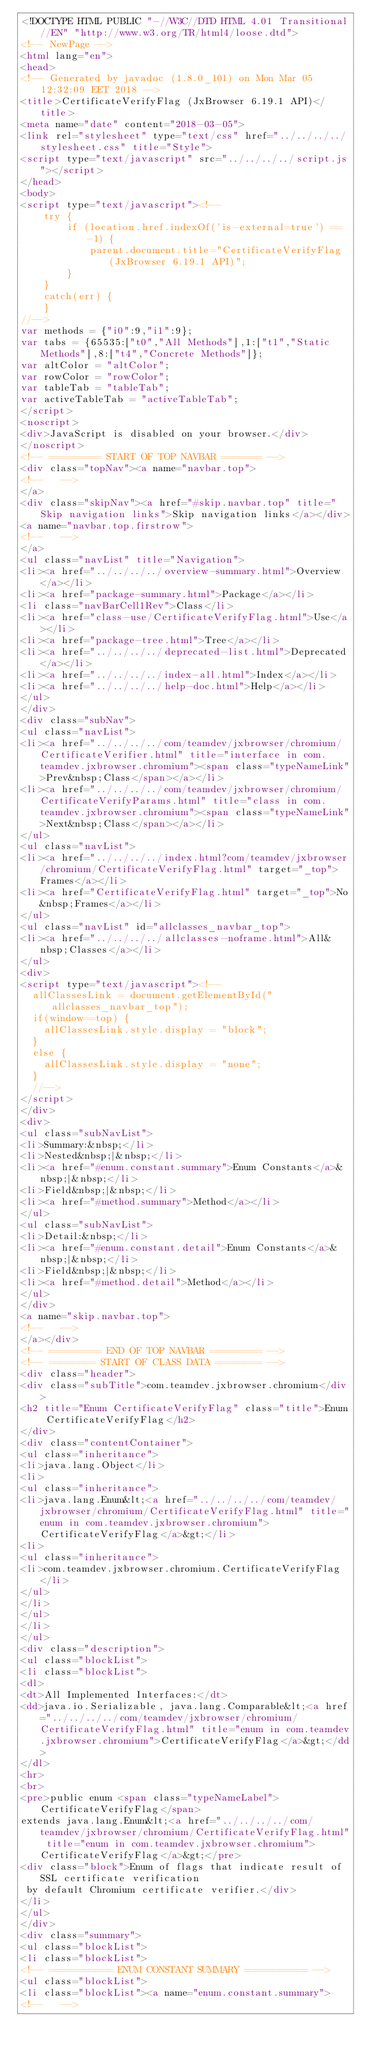Convert code to text. <code><loc_0><loc_0><loc_500><loc_500><_HTML_><!DOCTYPE HTML PUBLIC "-//W3C//DTD HTML 4.01 Transitional//EN" "http://www.w3.org/TR/html4/loose.dtd">
<!-- NewPage -->
<html lang="en">
<head>
<!-- Generated by javadoc (1.8.0_101) on Mon Mar 05 12:32:09 EET 2018 -->
<title>CertificateVerifyFlag (JxBrowser 6.19.1 API)</title>
<meta name="date" content="2018-03-05">
<link rel="stylesheet" type="text/css" href="../../../../stylesheet.css" title="Style">
<script type="text/javascript" src="../../../../script.js"></script>
</head>
<body>
<script type="text/javascript"><!--
    try {
        if (location.href.indexOf('is-external=true') == -1) {
            parent.document.title="CertificateVerifyFlag (JxBrowser 6.19.1 API)";
        }
    }
    catch(err) {
    }
//-->
var methods = {"i0":9,"i1":9};
var tabs = {65535:["t0","All Methods"],1:["t1","Static Methods"],8:["t4","Concrete Methods"]};
var altColor = "altColor";
var rowColor = "rowColor";
var tableTab = "tableTab";
var activeTableTab = "activeTableTab";
</script>
<noscript>
<div>JavaScript is disabled on your browser.</div>
</noscript>
<!-- ========= START OF TOP NAVBAR ======= -->
<div class="topNav"><a name="navbar.top">
<!--   -->
</a>
<div class="skipNav"><a href="#skip.navbar.top" title="Skip navigation links">Skip navigation links</a></div>
<a name="navbar.top.firstrow">
<!--   -->
</a>
<ul class="navList" title="Navigation">
<li><a href="../../../../overview-summary.html">Overview</a></li>
<li><a href="package-summary.html">Package</a></li>
<li class="navBarCell1Rev">Class</li>
<li><a href="class-use/CertificateVerifyFlag.html">Use</a></li>
<li><a href="package-tree.html">Tree</a></li>
<li><a href="../../../../deprecated-list.html">Deprecated</a></li>
<li><a href="../../../../index-all.html">Index</a></li>
<li><a href="../../../../help-doc.html">Help</a></li>
</ul>
</div>
<div class="subNav">
<ul class="navList">
<li><a href="../../../../com/teamdev/jxbrowser/chromium/CertificateVerifier.html" title="interface in com.teamdev.jxbrowser.chromium"><span class="typeNameLink">Prev&nbsp;Class</span></a></li>
<li><a href="../../../../com/teamdev/jxbrowser/chromium/CertificateVerifyParams.html" title="class in com.teamdev.jxbrowser.chromium"><span class="typeNameLink">Next&nbsp;Class</span></a></li>
</ul>
<ul class="navList">
<li><a href="../../../../index.html?com/teamdev/jxbrowser/chromium/CertificateVerifyFlag.html" target="_top">Frames</a></li>
<li><a href="CertificateVerifyFlag.html" target="_top">No&nbsp;Frames</a></li>
</ul>
<ul class="navList" id="allclasses_navbar_top">
<li><a href="../../../../allclasses-noframe.html">All&nbsp;Classes</a></li>
</ul>
<div>
<script type="text/javascript"><!--
  allClassesLink = document.getElementById("allclasses_navbar_top");
  if(window==top) {
    allClassesLink.style.display = "block";
  }
  else {
    allClassesLink.style.display = "none";
  }
  //-->
</script>
</div>
<div>
<ul class="subNavList">
<li>Summary:&nbsp;</li>
<li>Nested&nbsp;|&nbsp;</li>
<li><a href="#enum.constant.summary">Enum Constants</a>&nbsp;|&nbsp;</li>
<li>Field&nbsp;|&nbsp;</li>
<li><a href="#method.summary">Method</a></li>
</ul>
<ul class="subNavList">
<li>Detail:&nbsp;</li>
<li><a href="#enum.constant.detail">Enum Constants</a>&nbsp;|&nbsp;</li>
<li>Field&nbsp;|&nbsp;</li>
<li><a href="#method.detail">Method</a></li>
</ul>
</div>
<a name="skip.navbar.top">
<!--   -->
</a></div>
<!-- ========= END OF TOP NAVBAR ========= -->
<!-- ======== START OF CLASS DATA ======== -->
<div class="header">
<div class="subTitle">com.teamdev.jxbrowser.chromium</div>
<h2 title="Enum CertificateVerifyFlag" class="title">Enum CertificateVerifyFlag</h2>
</div>
<div class="contentContainer">
<ul class="inheritance">
<li>java.lang.Object</li>
<li>
<ul class="inheritance">
<li>java.lang.Enum&lt;<a href="../../../../com/teamdev/jxbrowser/chromium/CertificateVerifyFlag.html" title="enum in com.teamdev.jxbrowser.chromium">CertificateVerifyFlag</a>&gt;</li>
<li>
<ul class="inheritance">
<li>com.teamdev.jxbrowser.chromium.CertificateVerifyFlag</li>
</ul>
</li>
</ul>
</li>
</ul>
<div class="description">
<ul class="blockList">
<li class="blockList">
<dl>
<dt>All Implemented Interfaces:</dt>
<dd>java.io.Serializable, java.lang.Comparable&lt;<a href="../../../../com/teamdev/jxbrowser/chromium/CertificateVerifyFlag.html" title="enum in com.teamdev.jxbrowser.chromium">CertificateVerifyFlag</a>&gt;</dd>
</dl>
<hr>
<br>
<pre>public enum <span class="typeNameLabel">CertificateVerifyFlag</span>
extends java.lang.Enum&lt;<a href="../../../../com/teamdev/jxbrowser/chromium/CertificateVerifyFlag.html" title="enum in com.teamdev.jxbrowser.chromium">CertificateVerifyFlag</a>&gt;</pre>
<div class="block">Enum of flags that indicate result of SSL certificate verification
 by default Chromium certificate verifier.</div>
</li>
</ul>
</div>
<div class="summary">
<ul class="blockList">
<li class="blockList">
<!-- =========== ENUM CONSTANT SUMMARY =========== -->
<ul class="blockList">
<li class="blockList"><a name="enum.constant.summary">
<!--   --></code> 